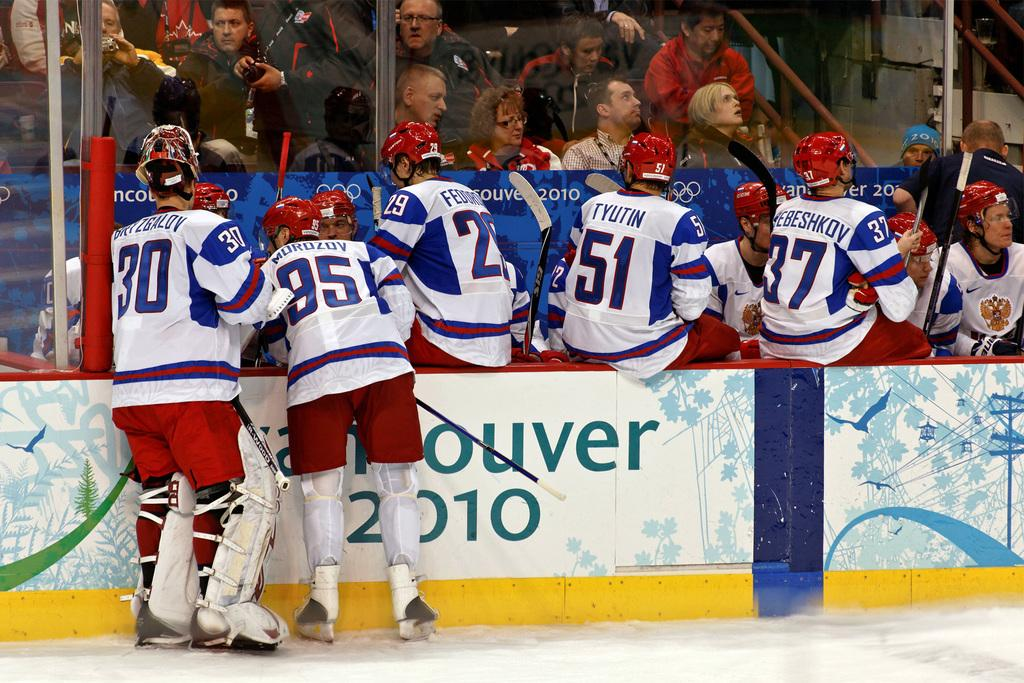<image>
Relay a brief, clear account of the picture shown. Alexei Morozov and his hockey teammates huddle in the pen during a 2010 game. 